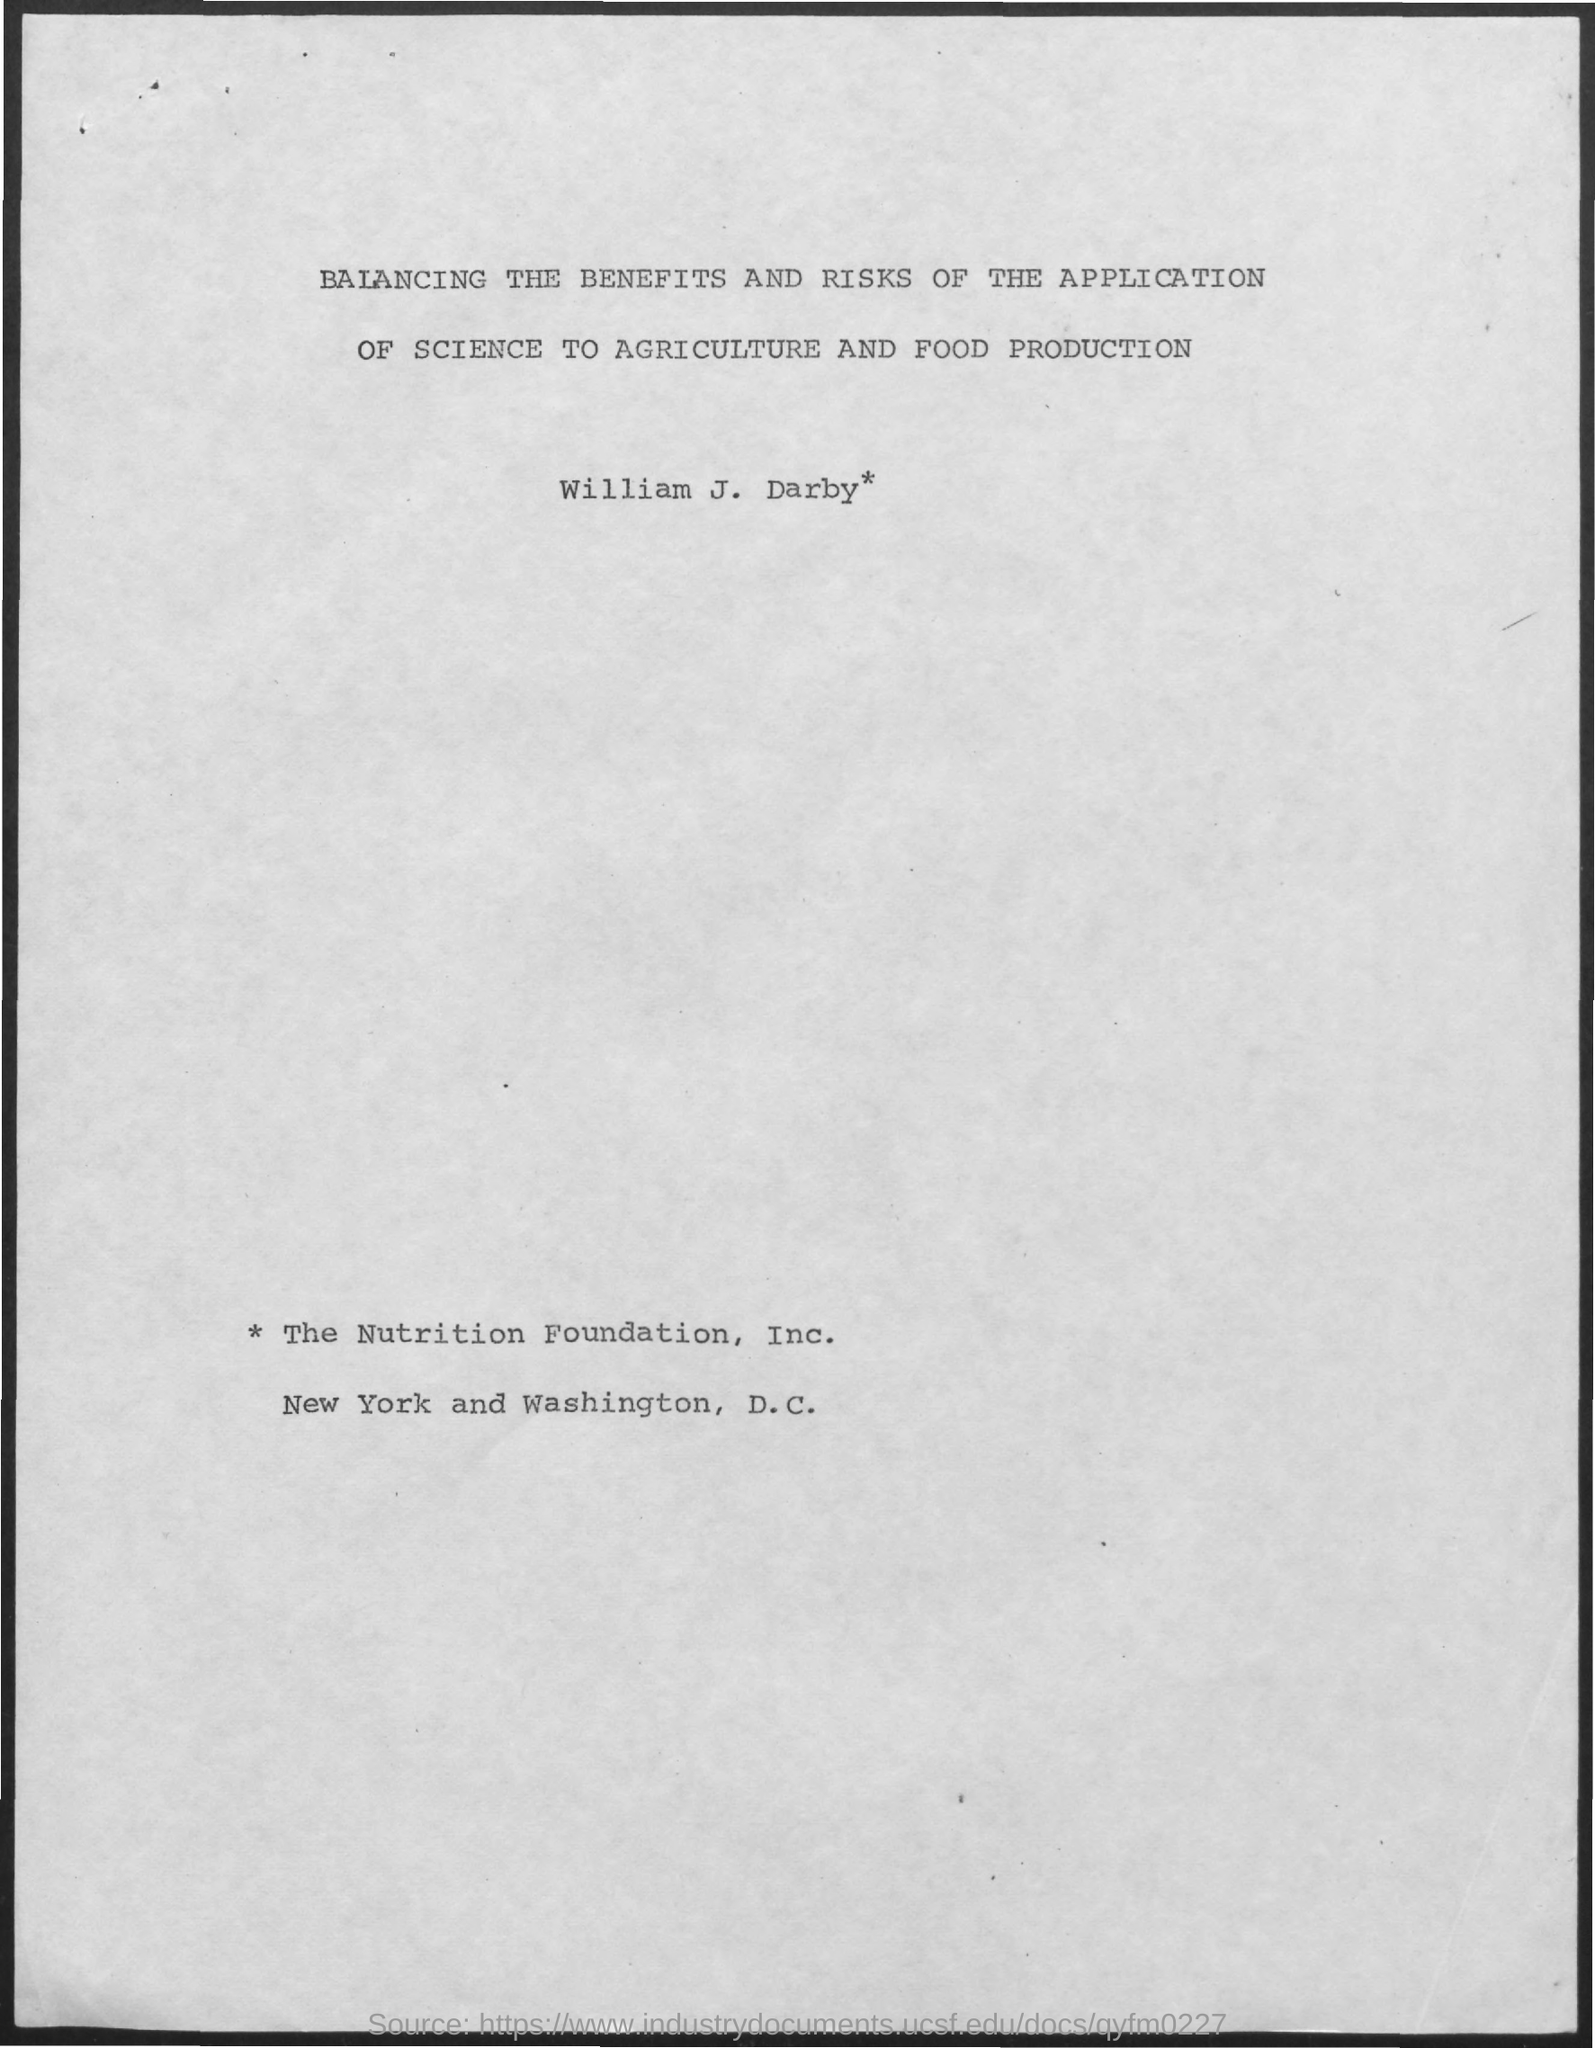What is the name of the person mentioned in the document?
Your response must be concise. William J. Darby*. What is the title of the document?
Your answer should be compact. Balancing the benefits and risks of the application of science to agriculture and food production. 